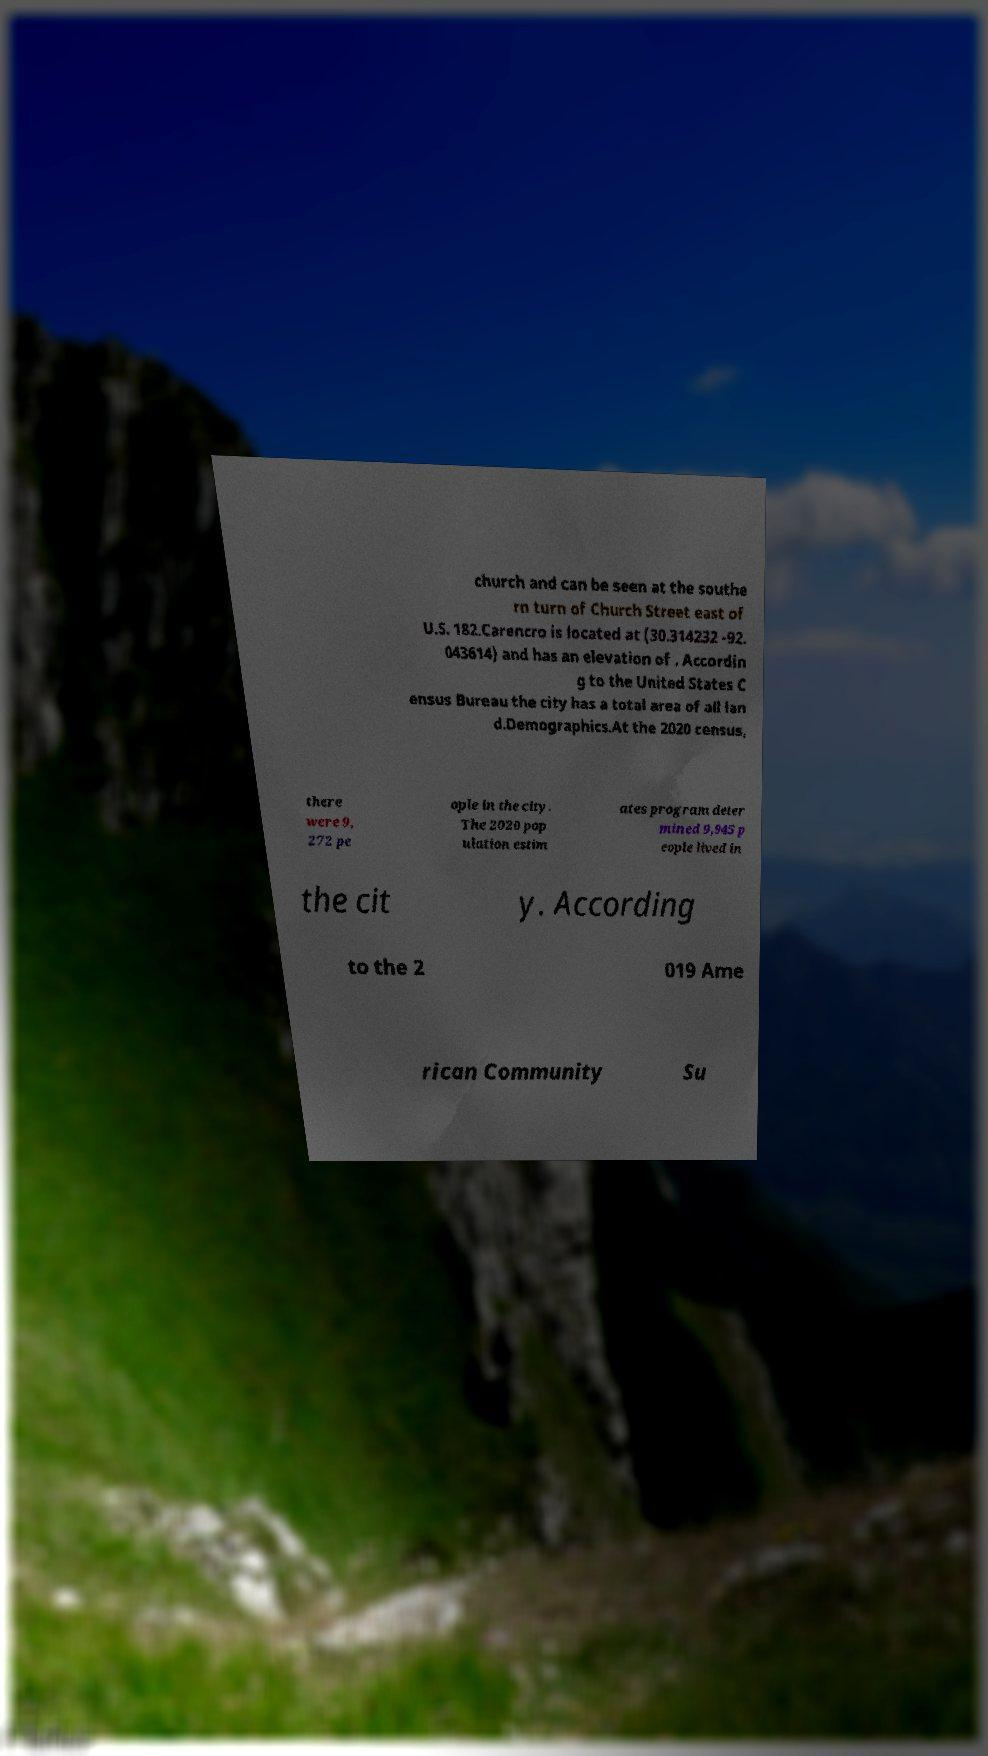Can you accurately transcribe the text from the provided image for me? church and can be seen at the southe rn turn of Church Street east of U.S. 182.Carencro is located at (30.314232 -92. 043614) and has an elevation of . Accordin g to the United States C ensus Bureau the city has a total area of all lan d.Demographics.At the 2020 census, there were 9, 272 pe ople in the city. The 2020 pop ulation estim ates program deter mined 9,945 p eople lived in the cit y. According to the 2 019 Ame rican Community Su 